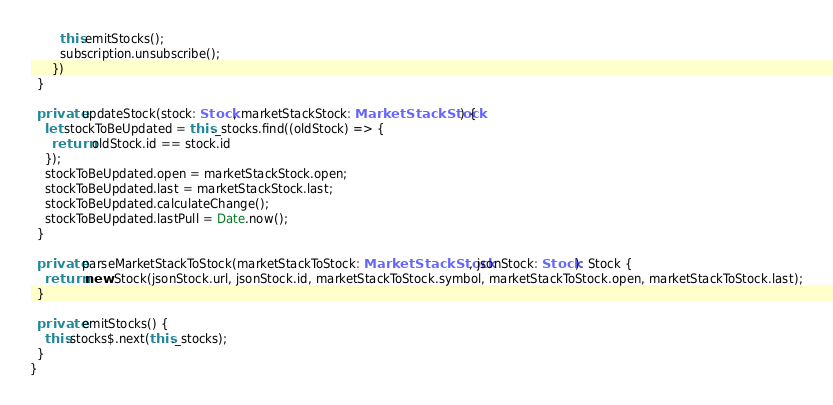Convert code to text. <code><loc_0><loc_0><loc_500><loc_500><_TypeScript_>        this.emitStocks();
        subscription.unsubscribe();
      })
  }

  private updateStock(stock: Stock, marketStackStock: MarketStackStock) {
    let stockToBeUpdated = this._stocks.find((oldStock) => {
      return oldStock.id == stock.id
    });
    stockToBeUpdated.open = marketStackStock.open;
    stockToBeUpdated.last = marketStackStock.last;
    stockToBeUpdated.calculateChange();
    stockToBeUpdated.lastPull = Date.now();
  }

  private parseMarketStackToStock(marketStackToStock: MarketStackStock, jsonStock: Stock): Stock {
    return new Stock(jsonStock.url, jsonStock.id, marketStackToStock.symbol, marketStackToStock.open, marketStackToStock.last);
  }

  private emitStocks() {
    this.stocks$.next(this._stocks);
  }
}
</code> 